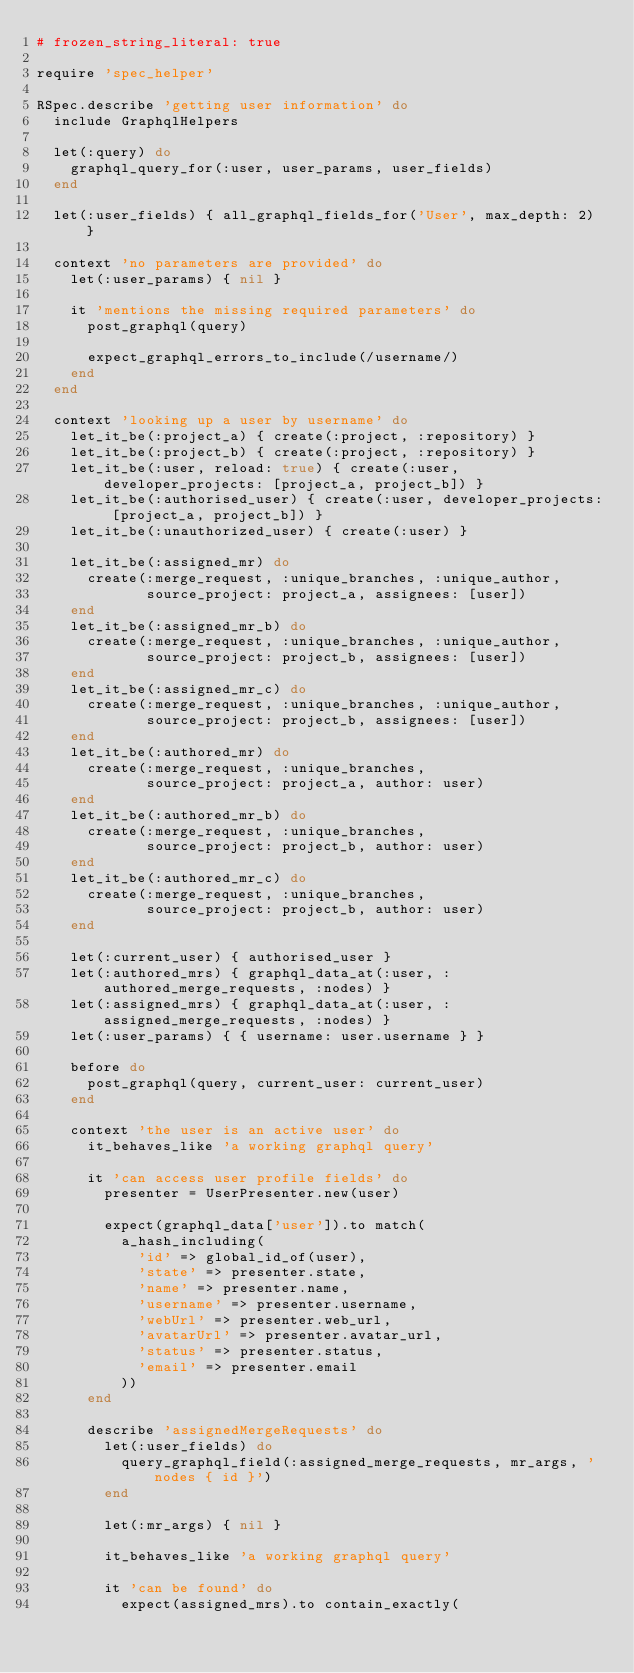<code> <loc_0><loc_0><loc_500><loc_500><_Ruby_># frozen_string_literal: true

require 'spec_helper'

RSpec.describe 'getting user information' do
  include GraphqlHelpers

  let(:query) do
    graphql_query_for(:user, user_params, user_fields)
  end

  let(:user_fields) { all_graphql_fields_for('User', max_depth: 2) }

  context 'no parameters are provided' do
    let(:user_params) { nil }

    it 'mentions the missing required parameters' do
      post_graphql(query)

      expect_graphql_errors_to_include(/username/)
    end
  end

  context 'looking up a user by username' do
    let_it_be(:project_a) { create(:project, :repository) }
    let_it_be(:project_b) { create(:project, :repository) }
    let_it_be(:user, reload: true) { create(:user, developer_projects: [project_a, project_b]) }
    let_it_be(:authorised_user) { create(:user, developer_projects: [project_a, project_b]) }
    let_it_be(:unauthorized_user) { create(:user) }

    let_it_be(:assigned_mr) do
      create(:merge_request, :unique_branches, :unique_author,
             source_project: project_a, assignees: [user])
    end
    let_it_be(:assigned_mr_b) do
      create(:merge_request, :unique_branches, :unique_author,
             source_project: project_b, assignees: [user])
    end
    let_it_be(:assigned_mr_c) do
      create(:merge_request, :unique_branches, :unique_author,
             source_project: project_b, assignees: [user])
    end
    let_it_be(:authored_mr) do
      create(:merge_request, :unique_branches,
             source_project: project_a, author: user)
    end
    let_it_be(:authored_mr_b) do
      create(:merge_request, :unique_branches,
             source_project: project_b, author: user)
    end
    let_it_be(:authored_mr_c) do
      create(:merge_request, :unique_branches,
             source_project: project_b, author: user)
    end

    let(:current_user) { authorised_user }
    let(:authored_mrs) { graphql_data_at(:user, :authored_merge_requests, :nodes) }
    let(:assigned_mrs) { graphql_data_at(:user, :assigned_merge_requests, :nodes) }
    let(:user_params) { { username: user.username } }

    before do
      post_graphql(query, current_user: current_user)
    end

    context 'the user is an active user' do
      it_behaves_like 'a working graphql query'

      it 'can access user profile fields' do
        presenter = UserPresenter.new(user)

        expect(graphql_data['user']).to match(
          a_hash_including(
            'id' => global_id_of(user),
            'state' => presenter.state,
            'name' => presenter.name,
            'username' => presenter.username,
            'webUrl' => presenter.web_url,
            'avatarUrl' => presenter.avatar_url,
            'status' => presenter.status,
            'email' => presenter.email
          ))
      end

      describe 'assignedMergeRequests' do
        let(:user_fields) do
          query_graphql_field(:assigned_merge_requests, mr_args, 'nodes { id }')
        end

        let(:mr_args) { nil }

        it_behaves_like 'a working graphql query'

        it 'can be found' do
          expect(assigned_mrs).to contain_exactly(</code> 